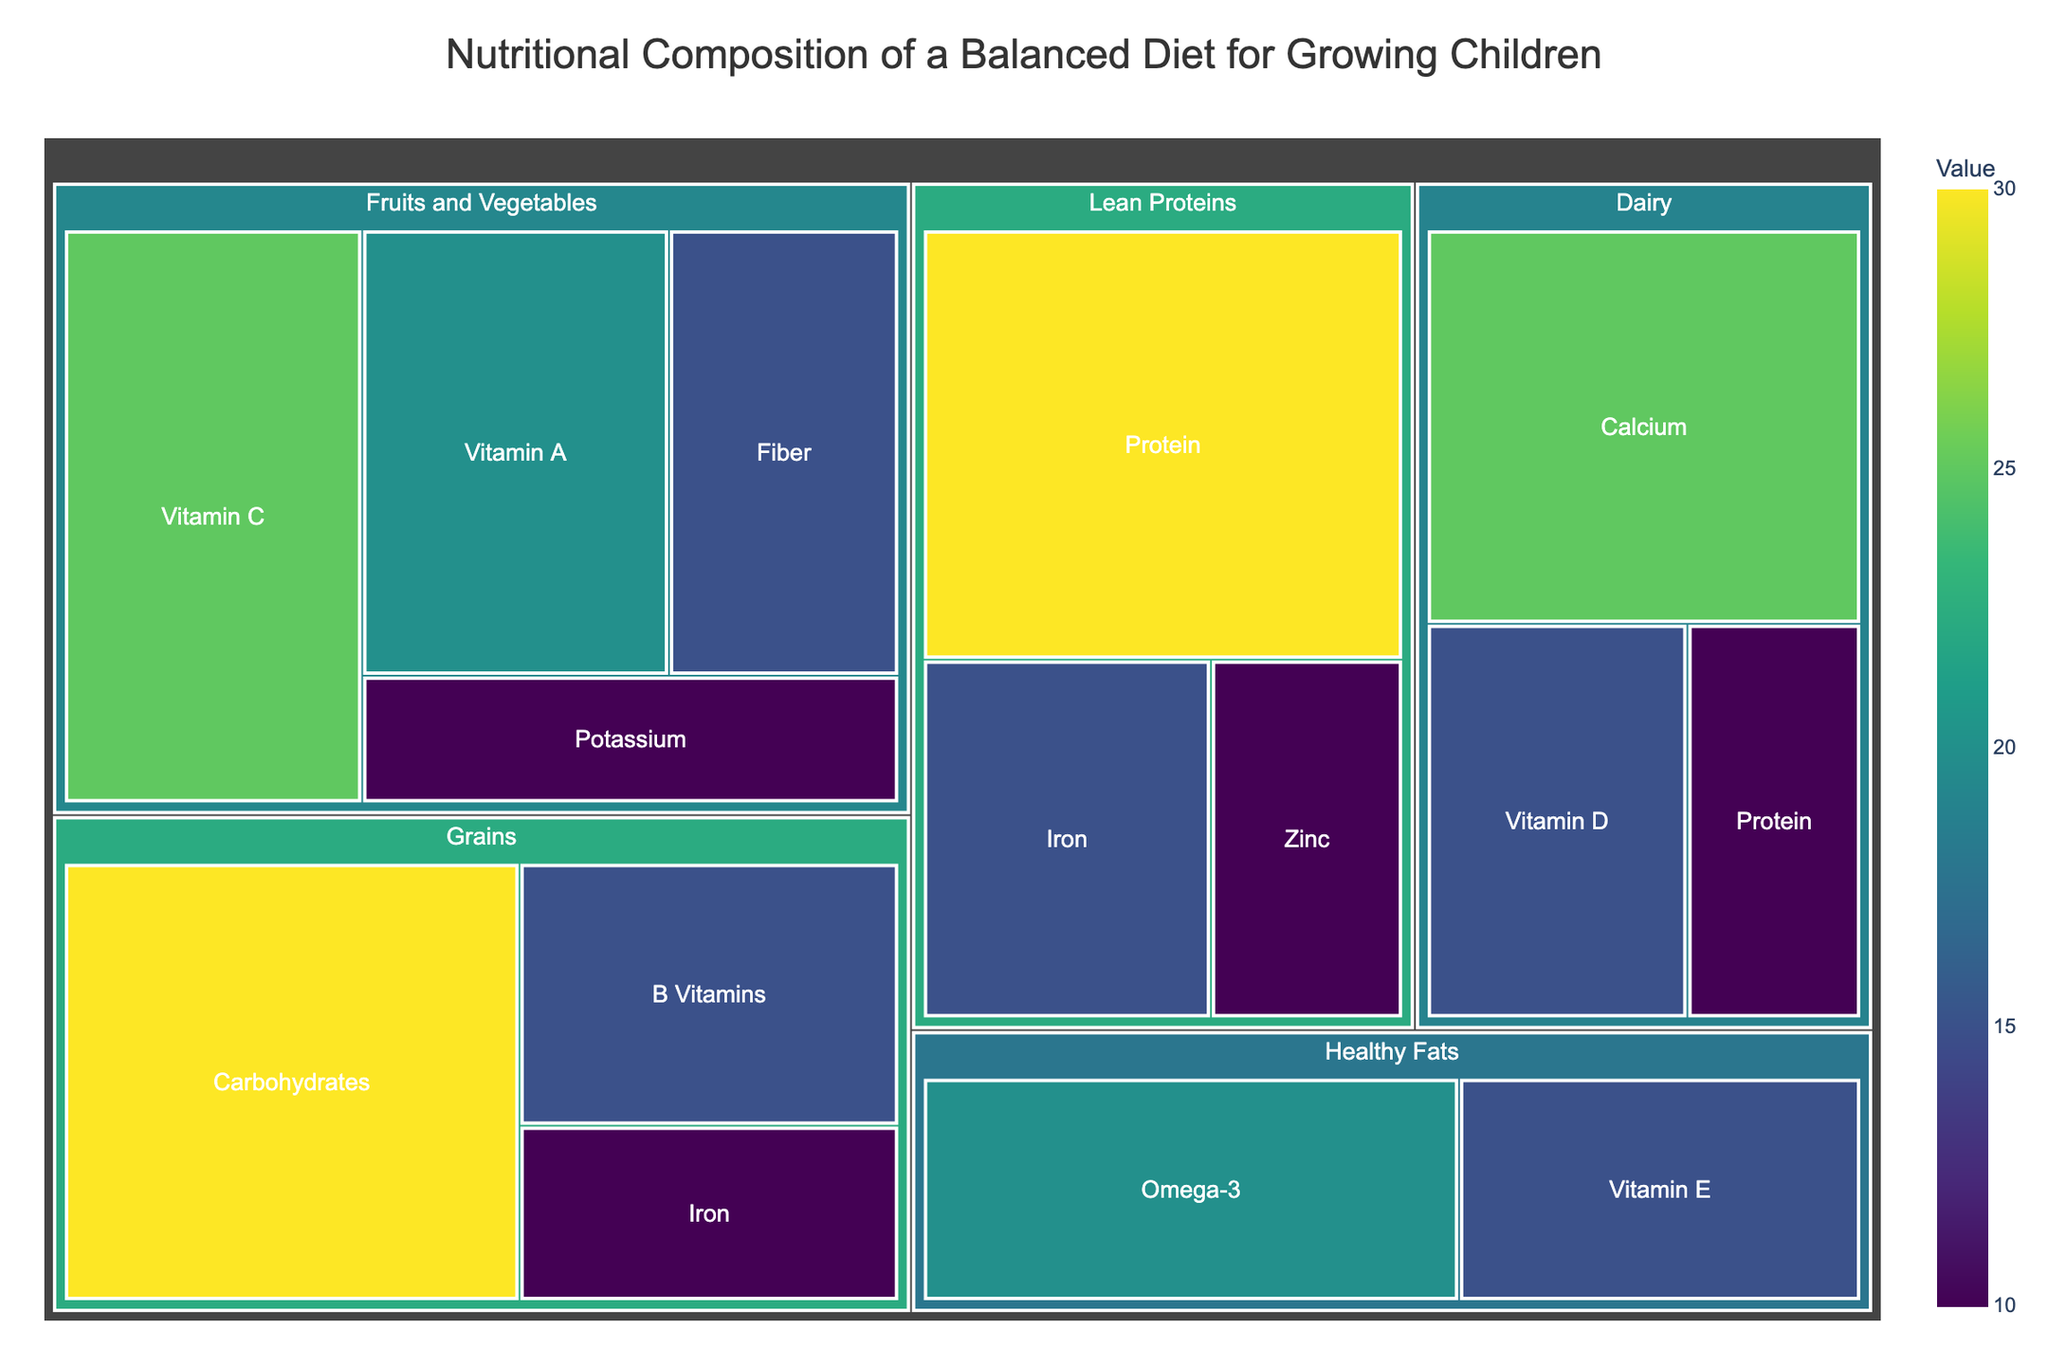Which food group provides the highest value in the treemap? The food group "Lean Proteins" has the highest single value entry with 30 for Protein.
Answer: Lean Proteins How much Vitamin C is provided by Fruits and Vegetables? The treemap shows Vitamin C under the "Fruits and Vegetables" category with a value of 25.
Answer: 25 Which essential nutrient has the lowest value within the Dairy group? In the Dairy group, Protein has the lowest value listed at 10.
Answer: Protein What is the total value provided by Grains? Add the values for Carbohydrates (30), B Vitamins (15), and Iron (10) within the Grains group: 30 + 15 + 10 = 55.
Answer: 55 Compare the value of Protein in Lean Proteins to Protein in Dairy. Which is higher? Lean Proteins has a value of 30 for Protein, whereas Dairy has a value of 10 for Protein. Therefore, Lean Proteins is higher.
Answer: Lean Proteins What is the sum of values of all nutrients provided by Fruits and Vegetables? Add the values for Vitamin C (25), Vitamin A (20), Fiber (15), and Potassium (10) within Fruits and Vegetables: 25 + 20 + 15 + 10 = 70.
Answer: 70 Which nutrient in the Healthy Fats group has the highest value? The Healthy Fats group lists Omega-3 with the highest value of 20.
Answer: Omega-3 How does the Iron value in Lean Proteins compare to the Iron value in Grains? Both Lean Proteins and Grains have the same value listed for Iron: 15.
Answer: Equal If you combine the values of Calcium and Vitamin D in Dairy, how much value do they provide together? Add the values for Calcium (25) and Vitamin D (15) within the Dairy group: 25 + 15 = 40.
Answer: 40 Which food group contributes the most Vitamin A? The only food group with Vitamin A listed is Fruits and Vegetables, providing a value of 20.
Answer: Fruits and Vegetables 